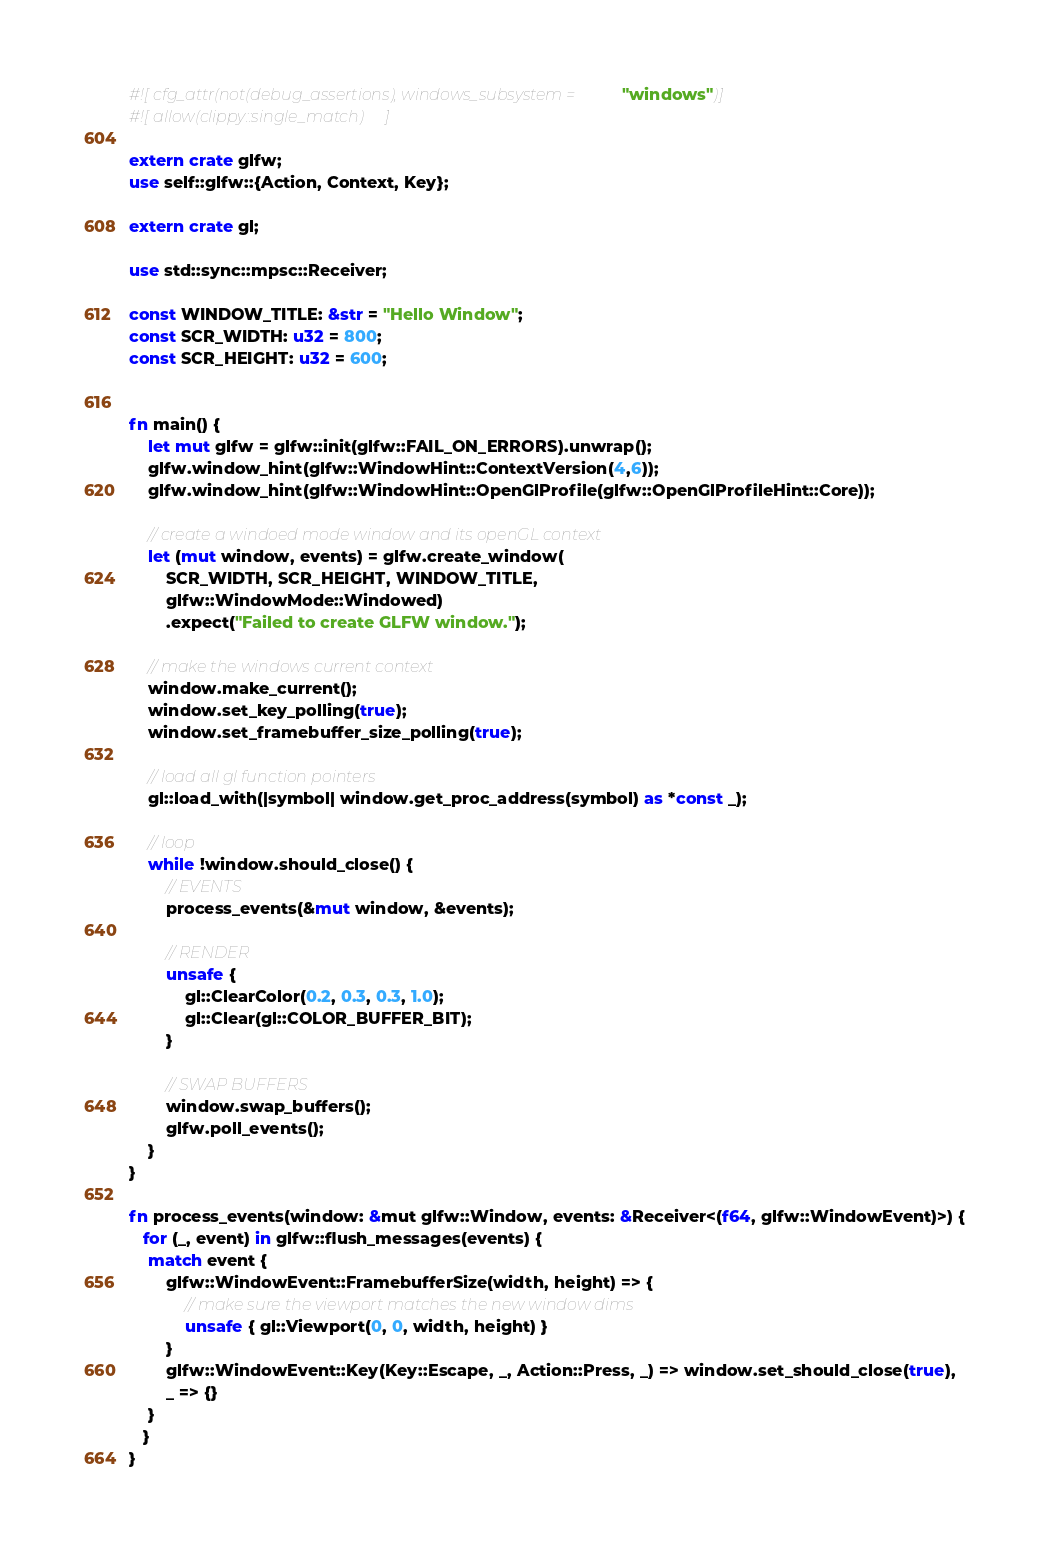<code> <loc_0><loc_0><loc_500><loc_500><_Rust_>#![cfg_attr(not(debug_assertions), windows_subsystem = "windows")]
#![allow(clippy::single_match)]

extern crate glfw;
use self::glfw::{Action, Context, Key};

extern crate gl;

use std::sync::mpsc::Receiver;

const WINDOW_TITLE: &str = "Hello Window";
const SCR_WIDTH: u32 = 800;
const SCR_HEIGHT: u32 = 600;


fn main() {
    let mut glfw = glfw::init(glfw::FAIL_ON_ERRORS).unwrap();
    glfw.window_hint(glfw::WindowHint::ContextVersion(4,6));
    glfw.window_hint(glfw::WindowHint::OpenGlProfile(glfw::OpenGlProfileHint::Core));

    // create a windoed mode window and its openGL context
    let (mut window, events) = glfw.create_window(
        SCR_WIDTH, SCR_HEIGHT, WINDOW_TITLE,
        glfw::WindowMode::Windowed)
        .expect("Failed to create GLFW window.");

    // make the windows current context
    window.make_current();
    window.set_key_polling(true);
    window.set_framebuffer_size_polling(true);

    // load all gl function pointers
    gl::load_with(|symbol| window.get_proc_address(symbol) as *const _);

    // loop
    while !window.should_close() {
        // EVENTS
        process_events(&mut window, &events);

        // RENDER
        unsafe {
            gl::ClearColor(0.2, 0.3, 0.3, 1.0);
            gl::Clear(gl::COLOR_BUFFER_BIT);
        }

        // SWAP BUFFERS
        window.swap_buffers();
        glfw.poll_events();
    }
}

fn process_events(window: &mut glfw::Window, events: &Receiver<(f64, glfw::WindowEvent)>) {
   for (_, event) in glfw::flush_messages(events) {
    match event {
        glfw::WindowEvent::FramebufferSize(width, height) => {
            // make sure the viewport matches the new window dims
            unsafe { gl::Viewport(0, 0, width, height) }
        }
        glfw::WindowEvent::Key(Key::Escape, _, Action::Press, _) => window.set_should_close(true),
        _ => {}
    }
   } 
}
</code> 